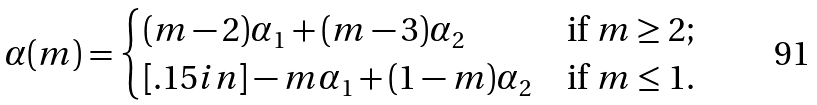<formula> <loc_0><loc_0><loc_500><loc_500>\alpha ( m ) = \begin{cases} ( m - 2 ) \alpha _ { 1 } + ( m - 3 ) \alpha _ { 2 } & \text {if $m \geq 2$;} \\ [ . 1 5 i n ] - m \alpha _ { 1 } + ( 1 - m ) \alpha _ { 2 } & \text {if $m \leq 1$.} \end{cases}</formula> 